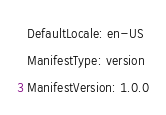Convert code to text. <code><loc_0><loc_0><loc_500><loc_500><_YAML_>DefaultLocale: en-US
ManifestType: version
ManifestVersion: 1.0.0
</code> 